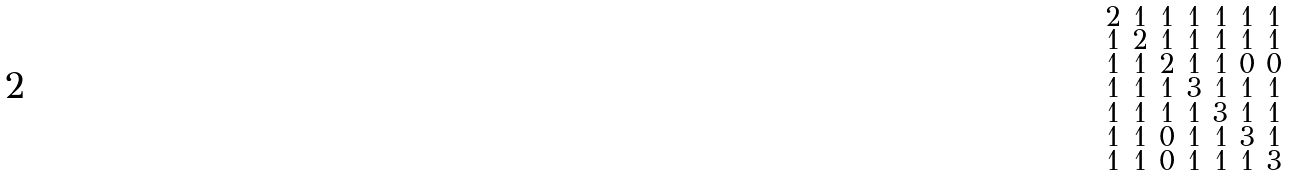Convert formula to latex. <formula><loc_0><loc_0><loc_500><loc_500>\begin{smallmatrix} 2 & 1 & 1 & 1 & 1 & 1 & 1 \\ 1 & 2 & 1 & 1 & 1 & 1 & 1 \\ 1 & 1 & 2 & 1 & 1 & 0 & 0 \\ 1 & 1 & 1 & 3 & 1 & 1 & 1 \\ 1 & 1 & 1 & 1 & 3 & 1 & 1 \\ 1 & 1 & 0 & 1 & 1 & 3 & 1 \\ 1 & 1 & 0 & 1 & 1 & 1 & 3 \end{smallmatrix}</formula> 